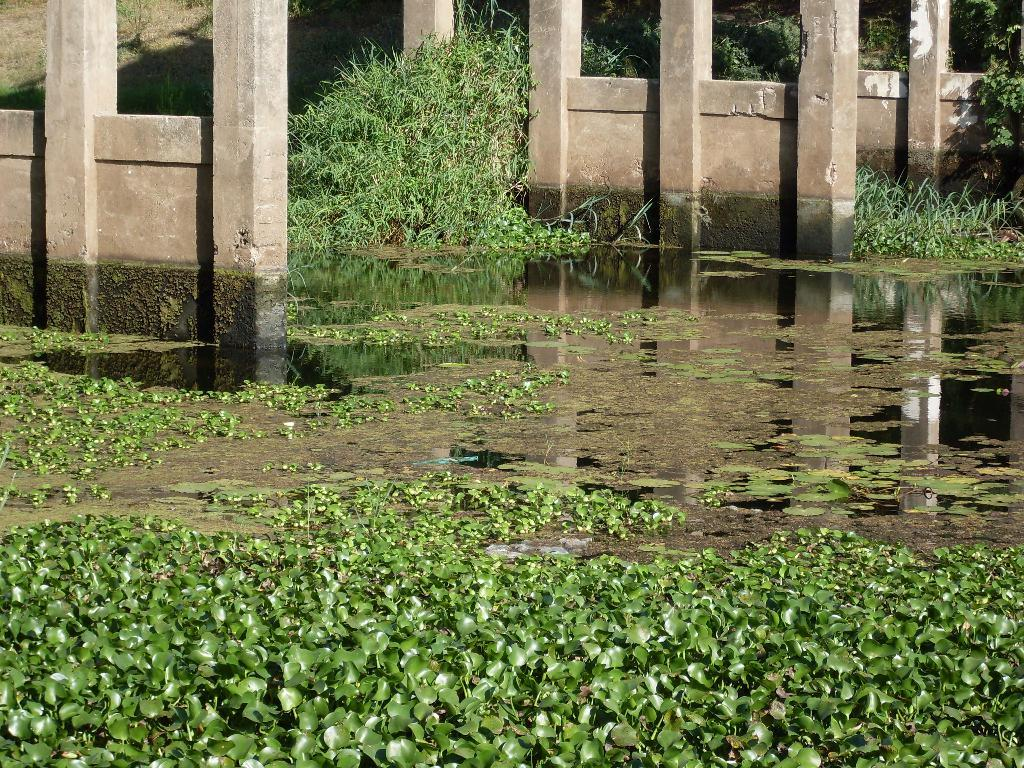What type of plants can be seen in the water in the image? There are lotus plants and other plants in the water in the image. What is the location of the plants in relation to the pillars? The plants are near pillars in the image. What can be seen in the background of the image? There is grass and plants on the ground in the background of the image. What type of fiction is being read by the elbow in the image? There is no elbow or fiction present in the image; it features plants in the water near pillars. 